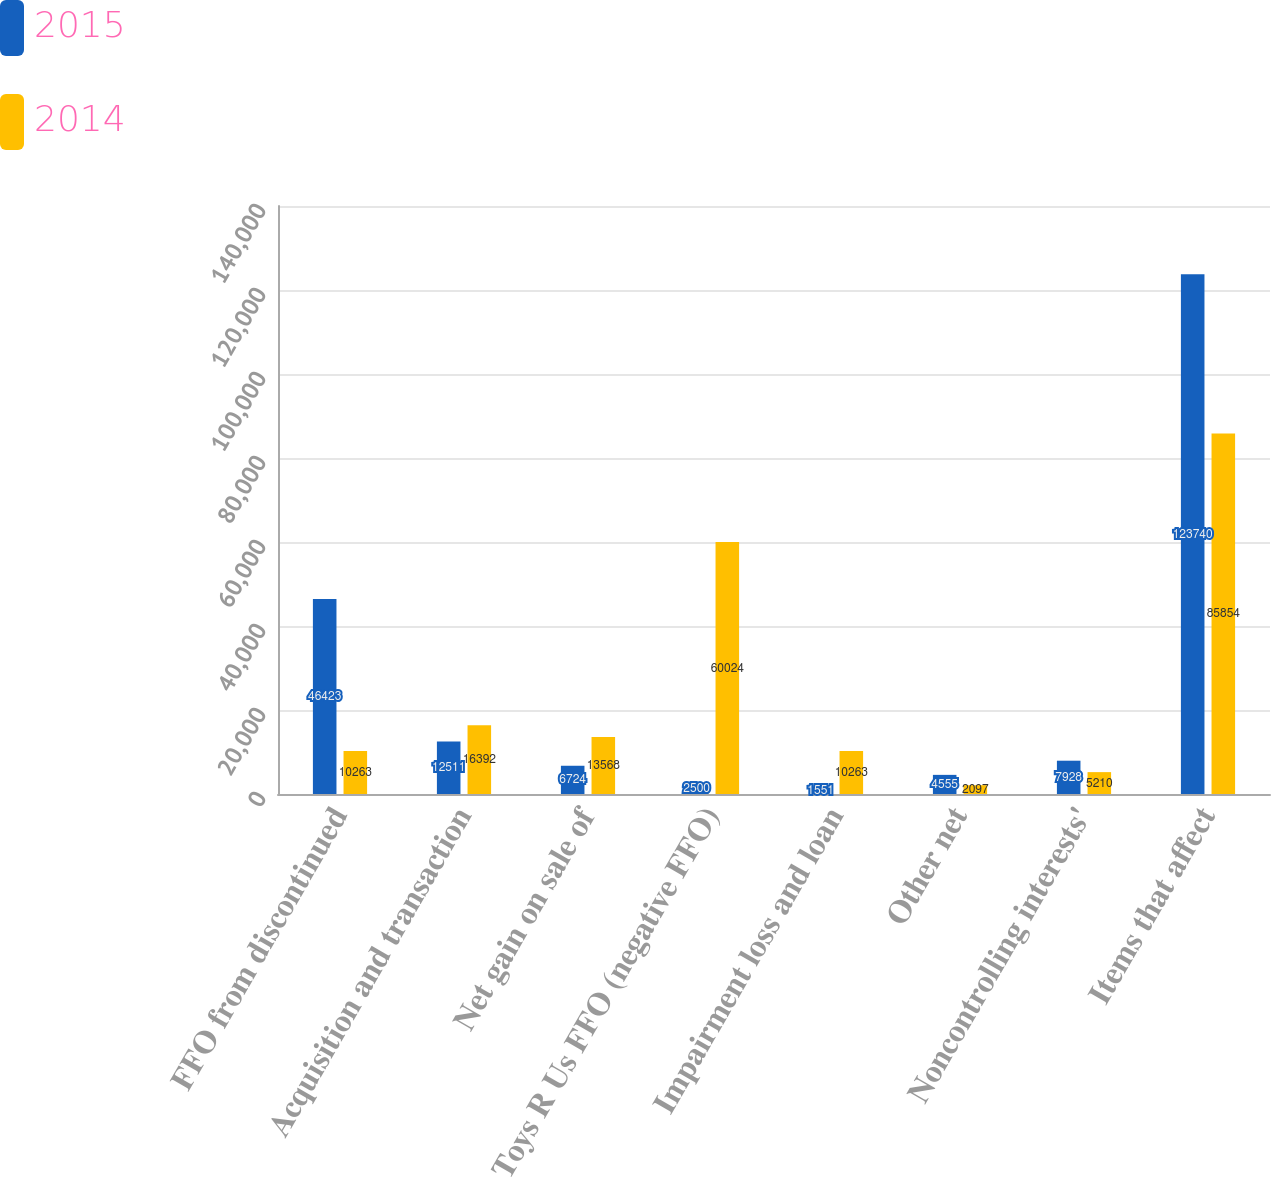<chart> <loc_0><loc_0><loc_500><loc_500><stacked_bar_chart><ecel><fcel>FFO from discontinued<fcel>Acquisition and transaction<fcel>Net gain on sale of<fcel>Toys R Us FFO (negative FFO)<fcel>Impairment loss and loan<fcel>Other net<fcel>Noncontrolling interests'<fcel>Items that affect<nl><fcel>2015<fcel>46423<fcel>12511<fcel>6724<fcel>2500<fcel>1551<fcel>4555<fcel>7928<fcel>123740<nl><fcel>2014<fcel>10263<fcel>16392<fcel>13568<fcel>60024<fcel>10263<fcel>2097<fcel>5210<fcel>85854<nl></chart> 